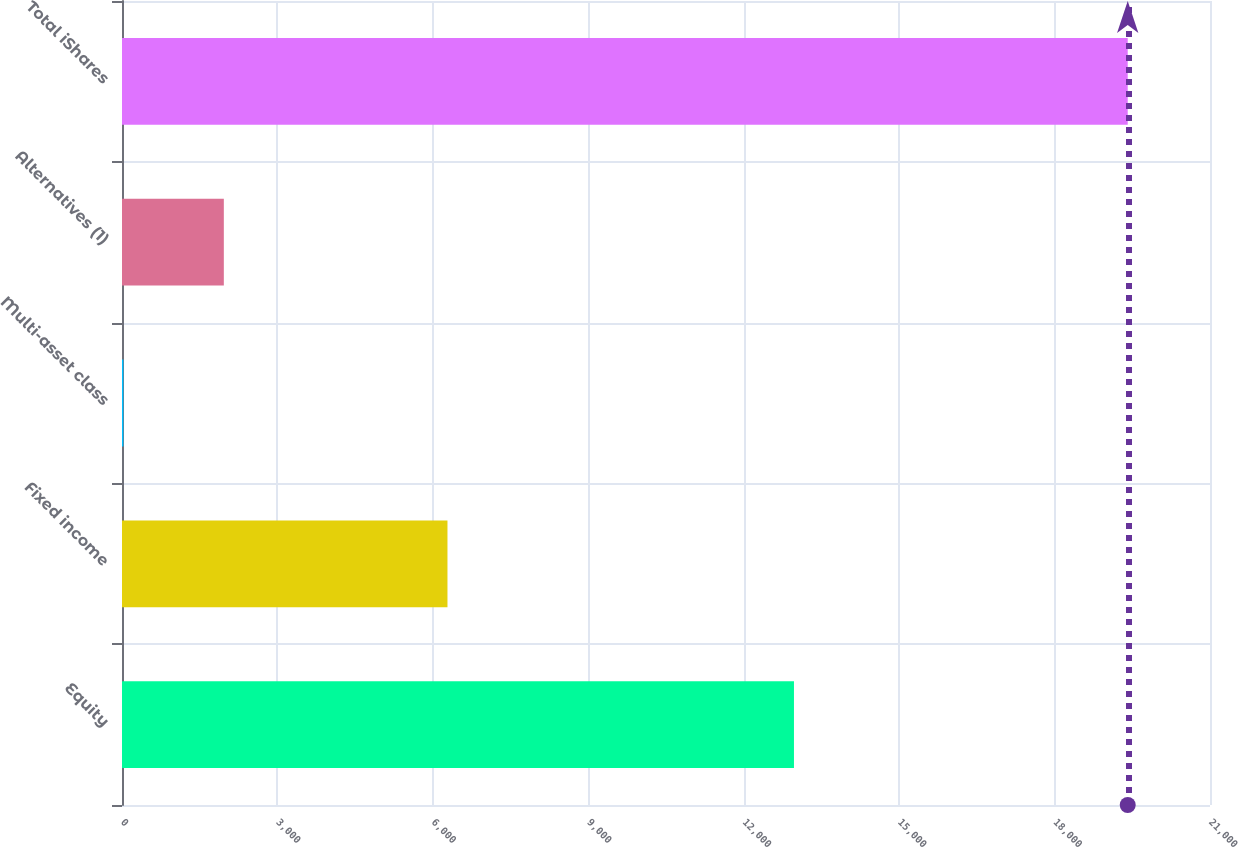<chart> <loc_0><loc_0><loc_500><loc_500><bar_chart><fcel>Equity<fcel>Fixed income<fcel>Multi-asset class<fcel>Alternatives (1)<fcel>Total iShares<nl><fcel>12970<fcel>6282<fcel>27<fcel>1965.5<fcel>19412<nl></chart> 